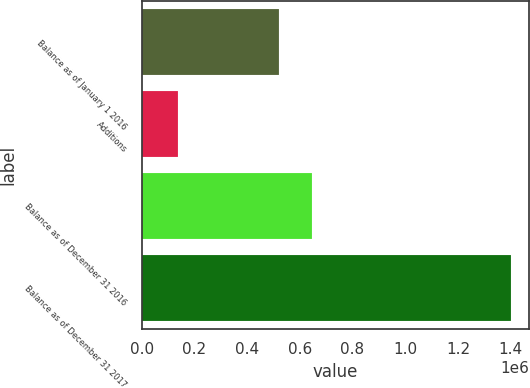Convert chart to OTSL. <chart><loc_0><loc_0><loc_500><loc_500><bar_chart><fcel>Balance as of January 1 2016<fcel>Additions<fcel>Balance as of December 31 2016<fcel>Balance as of December 31 2017<nl><fcel>521213<fcel>139982<fcel>647254<fcel>1.40039e+06<nl></chart> 